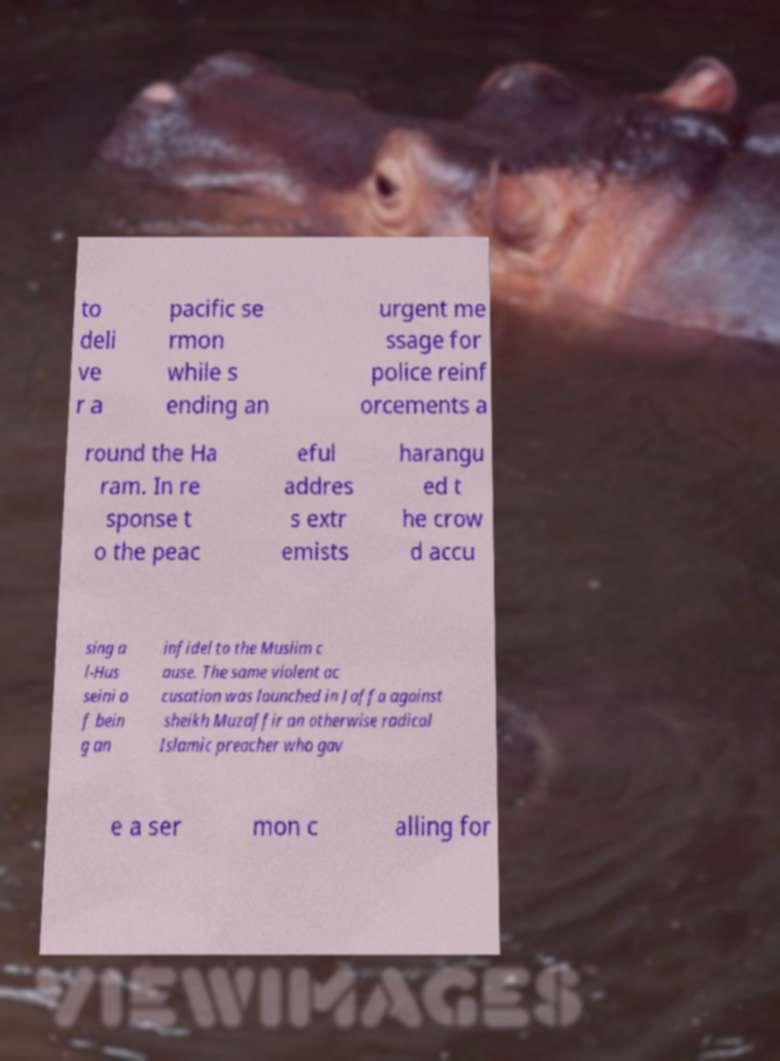Please identify and transcribe the text found in this image. to deli ve r a pacific se rmon while s ending an urgent me ssage for police reinf orcements a round the Ha ram. In re sponse t o the peac eful addres s extr emists harangu ed t he crow d accu sing a l-Hus seini o f bein g an infidel to the Muslim c ause. The same violent ac cusation was launched in Jaffa against sheikh Muzaffir an otherwise radical Islamic preacher who gav e a ser mon c alling for 